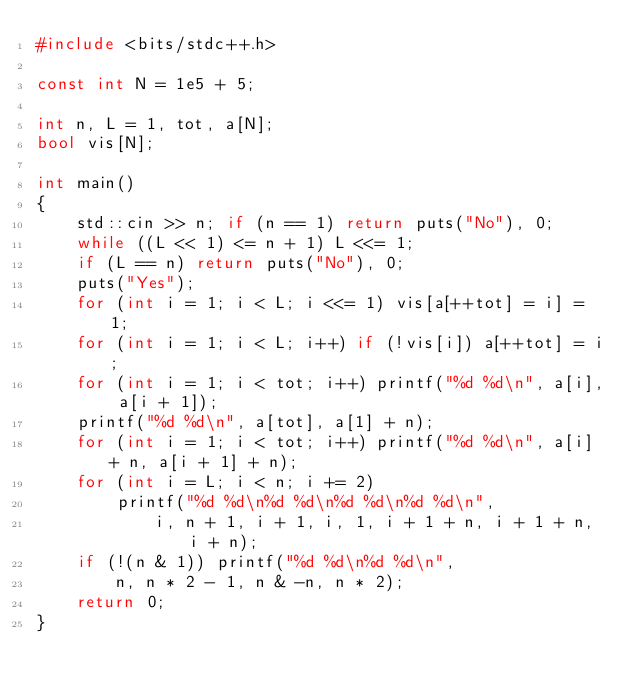Convert code to text. <code><loc_0><loc_0><loc_500><loc_500><_C++_>#include <bits/stdc++.h>

const int N = 1e5 + 5;

int n, L = 1, tot, a[N];
bool vis[N];

int main()
{
	std::cin >> n; if (n == 1) return puts("No"), 0;
	while ((L << 1) <= n + 1) L <<= 1;
	if (L == n) return puts("No"), 0;
	puts("Yes");
	for (int i = 1; i < L; i <<= 1) vis[a[++tot] = i] = 1;
	for (int i = 1; i < L; i++) if (!vis[i]) a[++tot] = i;
	for (int i = 1; i < tot; i++) printf("%d %d\n", a[i], a[i + 1]);
	printf("%d %d\n", a[tot], a[1] + n);
	for (int i = 1; i < tot; i++) printf("%d %d\n", a[i] + n, a[i + 1] + n);
	for (int i = L; i < n; i += 2)
		printf("%d %d\n%d %d\n%d %d\n%d %d\n",
			i, n + 1, i + 1, i, 1, i + 1 + n, i + 1 + n, i + n);
	if (!(n & 1)) printf("%d %d\n%d %d\n",
		n, n * 2 - 1, n & -n, n * 2);
	return 0;
}</code> 